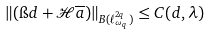<formula> <loc_0><loc_0><loc_500><loc_500>\| ( \i d + \mathcal { H } \overline { a } ) \| _ { B ( \ell ^ { 2 q } _ { \omega _ { q } } ) } \leq C ( d , \lambda )</formula> 